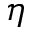<formula> <loc_0><loc_0><loc_500><loc_500>\eta</formula> 